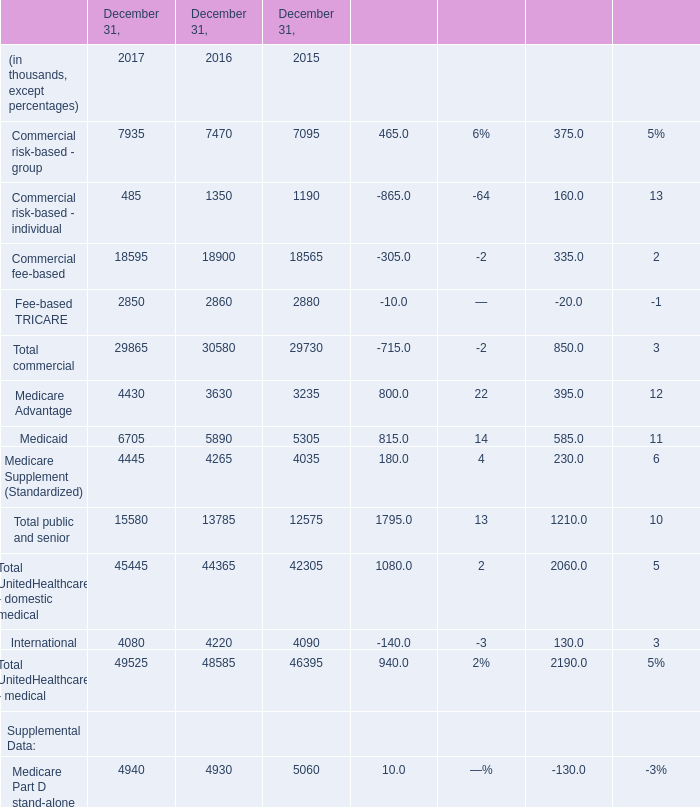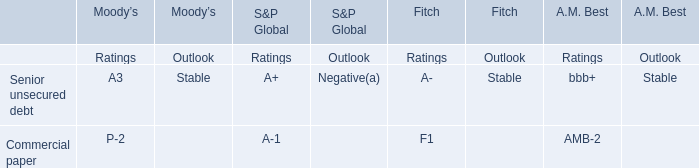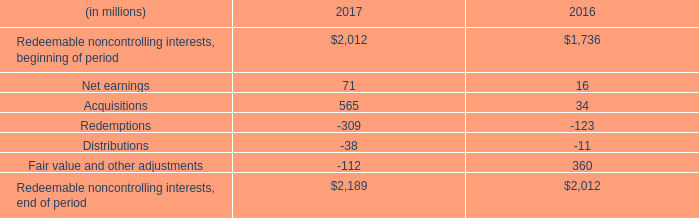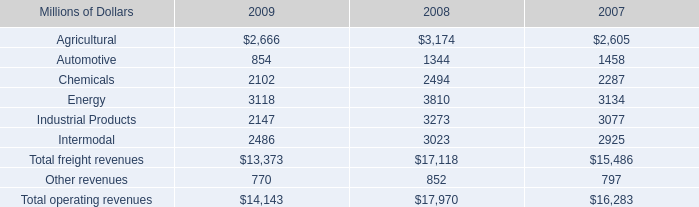What's the sum of Industrial Products of 2009, and Medicare Advantage of December 31, 2016 ? 
Computations: (2147.0 + 3630.0)
Answer: 5777.0. 